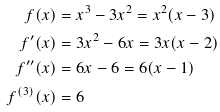Convert formula to latex. <formula><loc_0><loc_0><loc_500><loc_500>f ( x ) & = x ^ { 3 } - 3 x ^ { 2 } = x ^ { 2 } ( x - 3 ) \\ f ^ { \prime } ( x ) & = 3 x ^ { 2 } - 6 x = 3 x ( x - 2 ) \\ f ^ { \prime \prime } ( x ) & = 6 x - 6 = 6 ( x - 1 ) \\ f ^ { ( 3 ) } ( x ) & = 6</formula> 